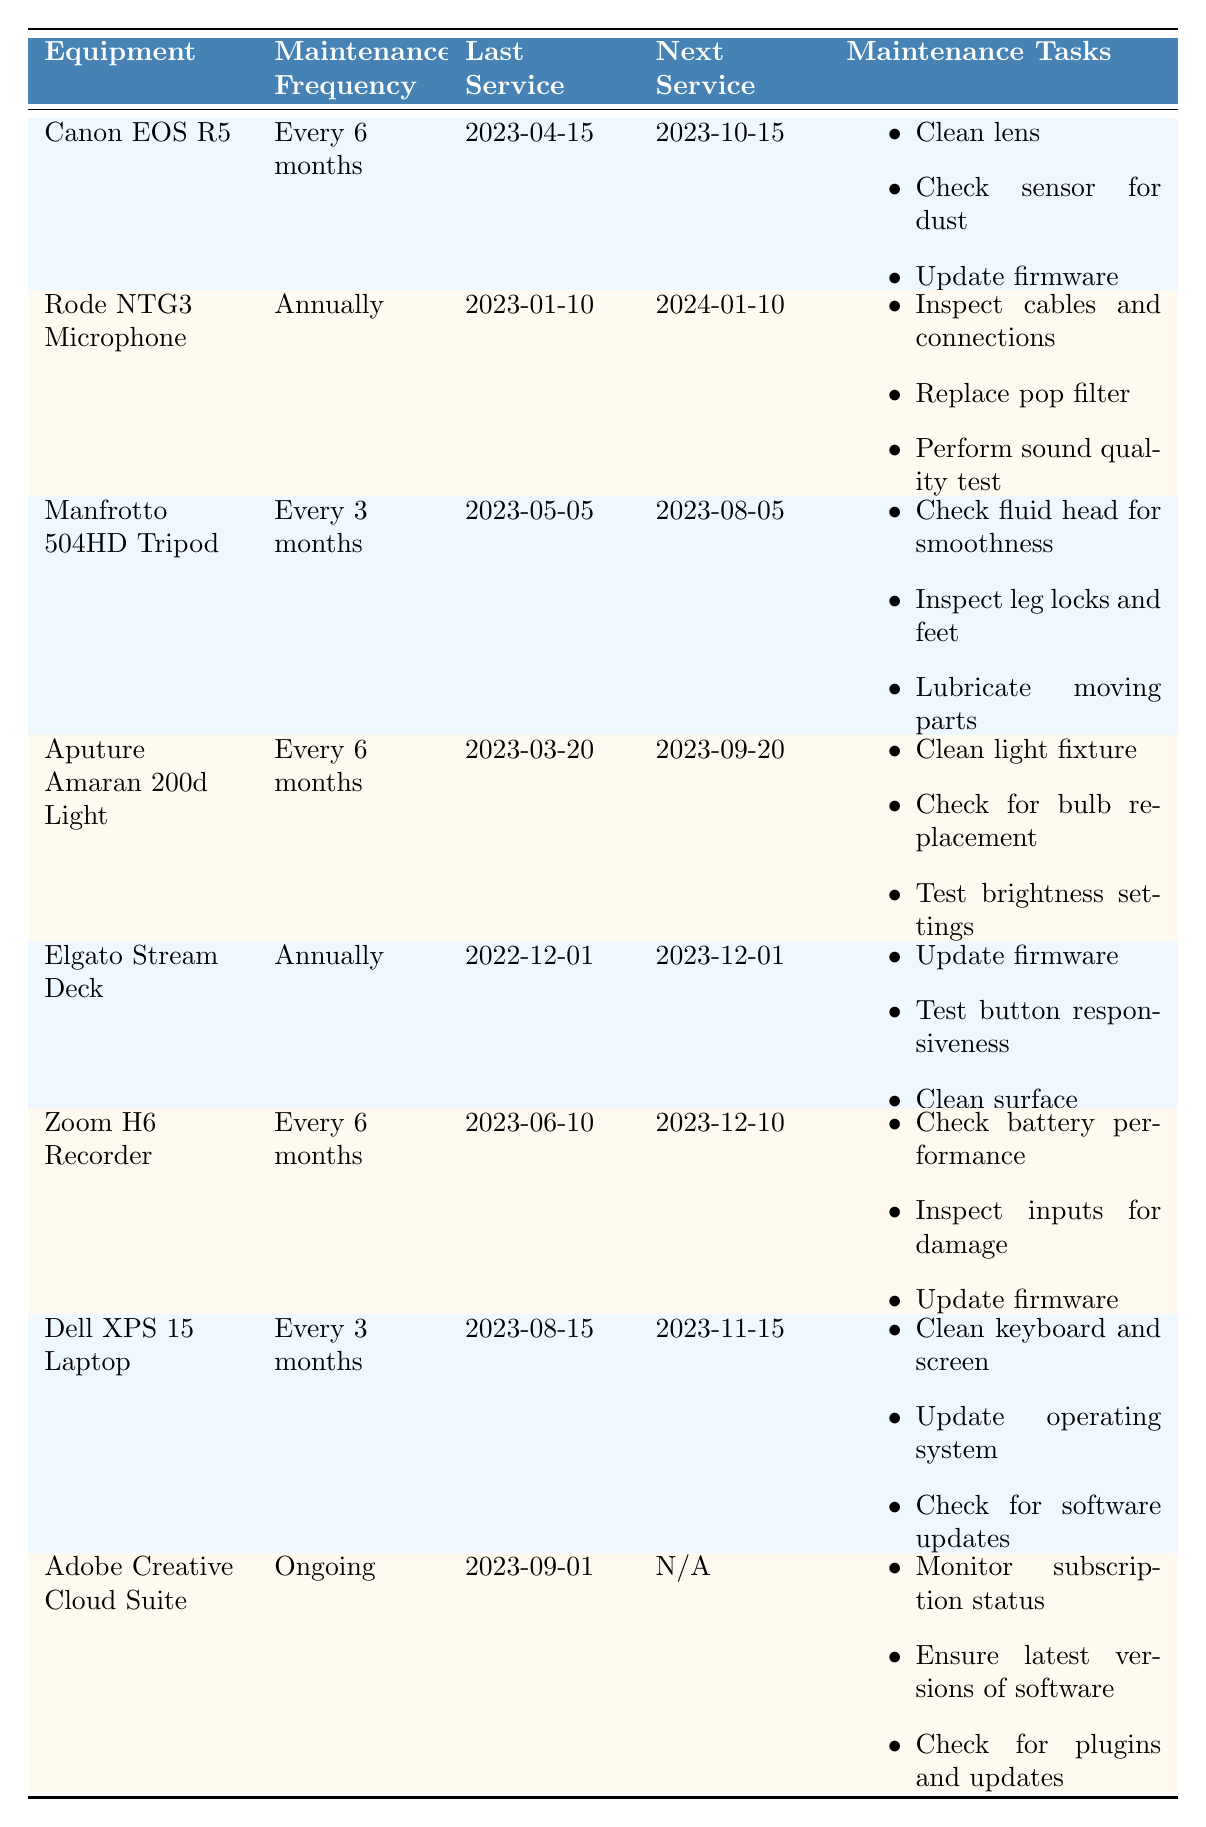What is the maintenance frequency for the Canon EOS R5? The table clearly states that the maintenance frequency for the Canon EOS R5 is "Every 6 months."
Answer: Every 6 months When is the next service due for the Rode NTG3 Microphone? The last service date for the Rode NTG3 Microphone is January 10, 2023, and the next service due date is listed as January 10, 2024.
Answer: January 10, 2024 How many pieces of equipment are scheduled for maintenance every 3 months? The Manfrotto 504HD Tripod and Dell XPS 15 Laptop both have a maintenance frequency of "Every 3 months." Counting these gives a total of 2 pieces of equipment.
Answer: 2 Is the last service date for the Aputure Amaran 200d Light after the last service date for the Elgato Stream Deck? The last service date for the Aputure Amaran 200d Light is March 20, 2023, while the last service date for the Elgato Stream Deck is December 1, 2022. Since March 20, 2023, is after December 1, 2022, the answer is yes.
Answer: Yes What maintenance tasks are required for the Zoom H6 Recorder? For the Zoom H6 Recorder, the maintenance tasks are: check battery performance, inspect inputs for damage, and update firmware. Each task is listed in the table.
Answer: Check battery performance, inspect inputs for damage, update firmware How many equipment pieces have a next service due in 2023? Reviewing the next service due dates in the table: Canon EOS R5 (October 15), Manfrotto 504HD Tripod (August 5), Aputure Amaran 200d Light (September 20), Zoom H6 Recorder (December 10), and Dell XPS 15 Laptop (November 15). The total count is 5 equipment pieces.
Answer: 5 Is it true that the Elgato Stream Deck is scheduled for maintenance more frequently than the Rode NTG3 Microphone? The Elgato Stream Deck has a maintenance frequency of "Annually," while the Rode NTG3 Microphone also has a frequency of "Annually." Thus, they are not scheduled more frequently than each other.
Answer: No What is the next service due date for equipment that requires servicing every 6 months? The equipment that requires maintenance every 6 months includes the Canon EOS R5 (next service due October 15, 2023), Aputure Amaran 200d Light (next service due September 20, 2023), and Zoom H6 Recorder (next service due December 10, 2023). The next service due dates are October 15, September 20, and December 10, respectively.
Answer: October 15, 2023; September 20, 2023; December 10, 2023 